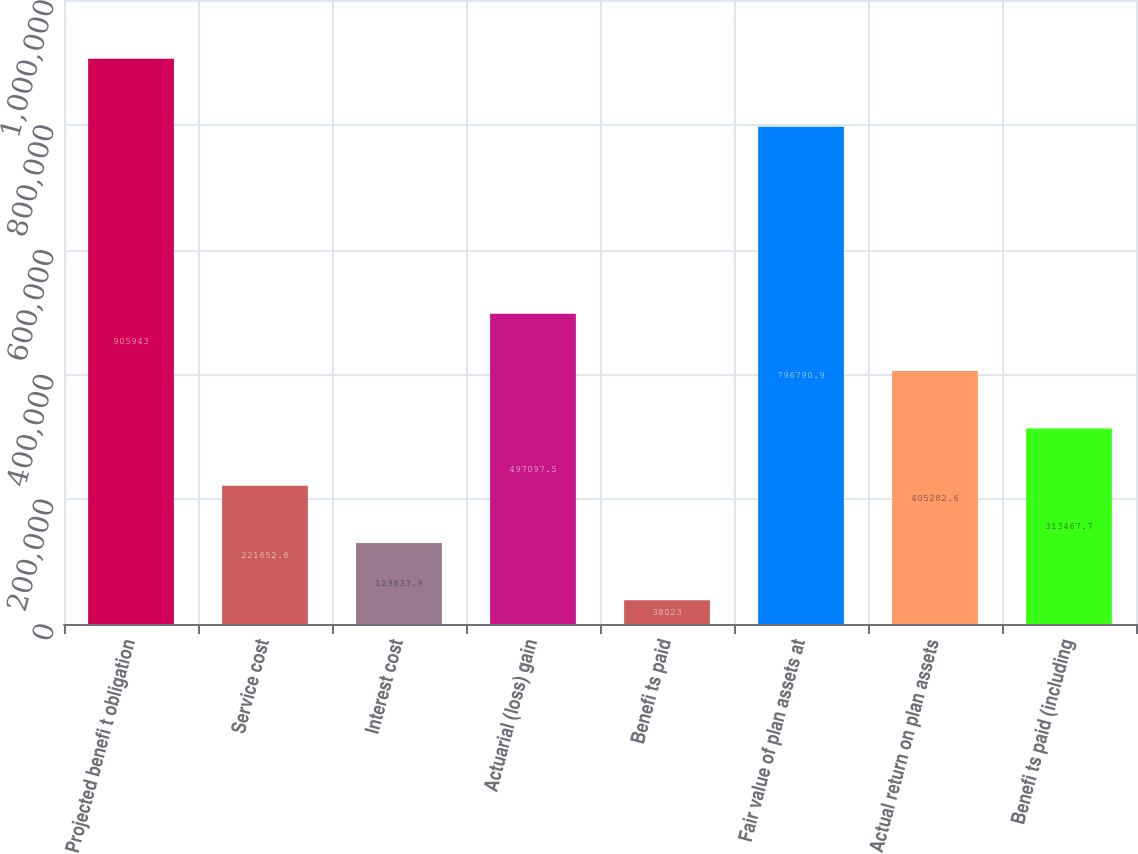<chart> <loc_0><loc_0><loc_500><loc_500><bar_chart><fcel>Projected benefi t obligation<fcel>Service cost<fcel>Interest cost<fcel>Actuarial (loss) gain<fcel>Benefi ts paid<fcel>Fair value of plan assets at<fcel>Actual return on plan assets<fcel>Benefi ts paid (including<nl><fcel>905943<fcel>221653<fcel>129838<fcel>497098<fcel>38023<fcel>796791<fcel>405283<fcel>313468<nl></chart> 